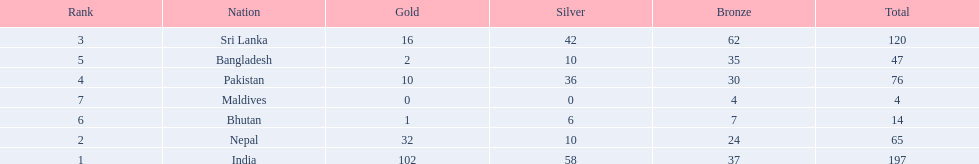Could you parse the entire table as a dict? {'header': ['Rank', 'Nation', 'Gold', 'Silver', 'Bronze', 'Total'], 'rows': [['3', 'Sri Lanka', '16', '42', '62', '120'], ['5', 'Bangladesh', '2', '10', '35', '47'], ['4', 'Pakistan', '10', '36', '30', '76'], ['7', 'Maldives', '0', '0', '4', '4'], ['6', 'Bhutan', '1', '6', '7', '14'], ['2', 'Nepal', '32', '10', '24', '65'], ['1', 'India', '102', '58', '37', '197']]} What countries attended the 1999 south asian games? India, Nepal, Sri Lanka, Pakistan, Bangladesh, Bhutan, Maldives. Which of these countries had 32 gold medals? Nepal. 